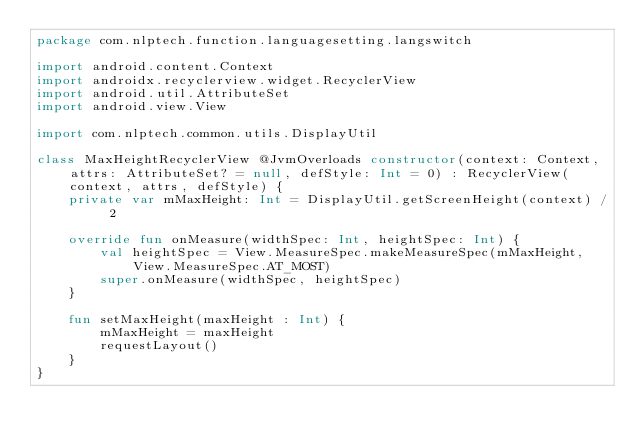Convert code to text. <code><loc_0><loc_0><loc_500><loc_500><_Kotlin_>package com.nlptech.function.languagesetting.langswitch

import android.content.Context
import androidx.recyclerview.widget.RecyclerView
import android.util.AttributeSet
import android.view.View

import com.nlptech.common.utils.DisplayUtil

class MaxHeightRecyclerView @JvmOverloads constructor(context: Context, attrs: AttributeSet? = null, defStyle: Int = 0) : RecyclerView(context, attrs, defStyle) {
    private var mMaxHeight: Int = DisplayUtil.getScreenHeight(context) / 2

    override fun onMeasure(widthSpec: Int, heightSpec: Int) {
        val heightSpec = View.MeasureSpec.makeMeasureSpec(mMaxHeight, View.MeasureSpec.AT_MOST)
        super.onMeasure(widthSpec, heightSpec)
    }

    fun setMaxHeight(maxHeight : Int) {
        mMaxHeight = maxHeight
        requestLayout()
    }
}
</code> 